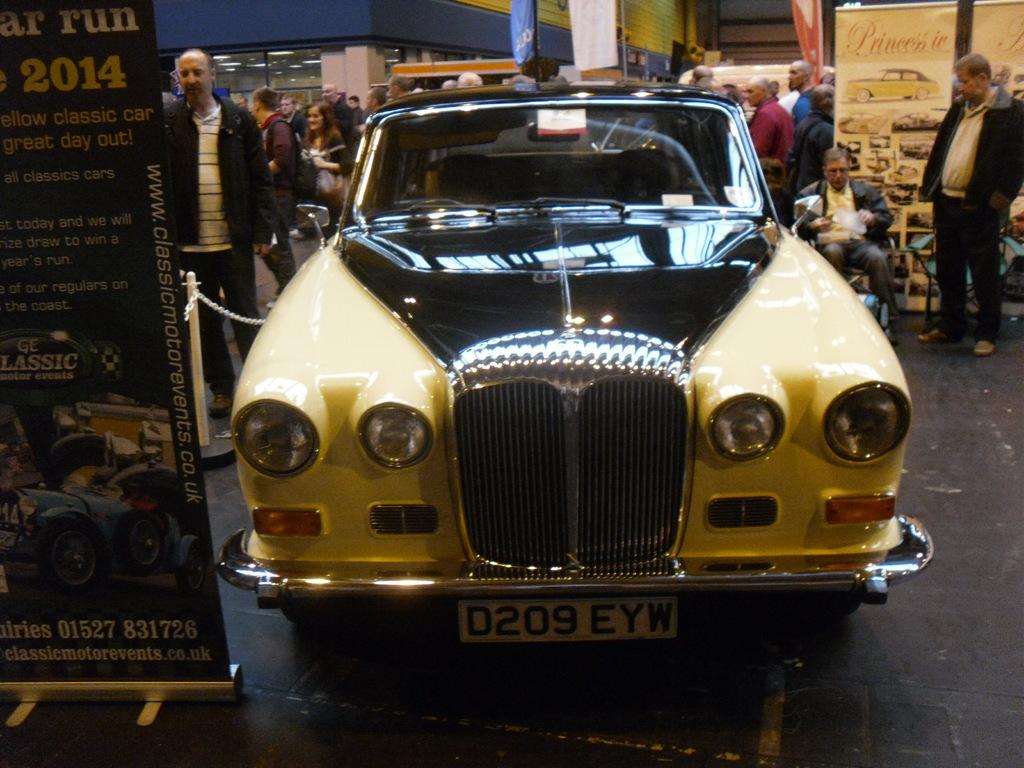What year is on the sign beside the black and yellow card?
Provide a short and direct response. 2014. What is the license plate number?
Keep it short and to the point. D209 eyw. 